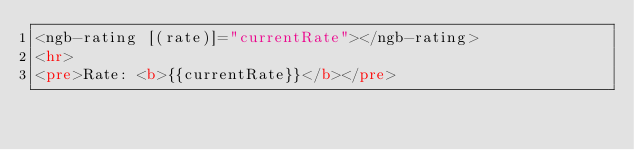<code> <loc_0><loc_0><loc_500><loc_500><_HTML_><ngb-rating [(rate)]="currentRate"></ngb-rating>
<hr>
<pre>Rate: <b>{{currentRate}}</b></pre>
</code> 